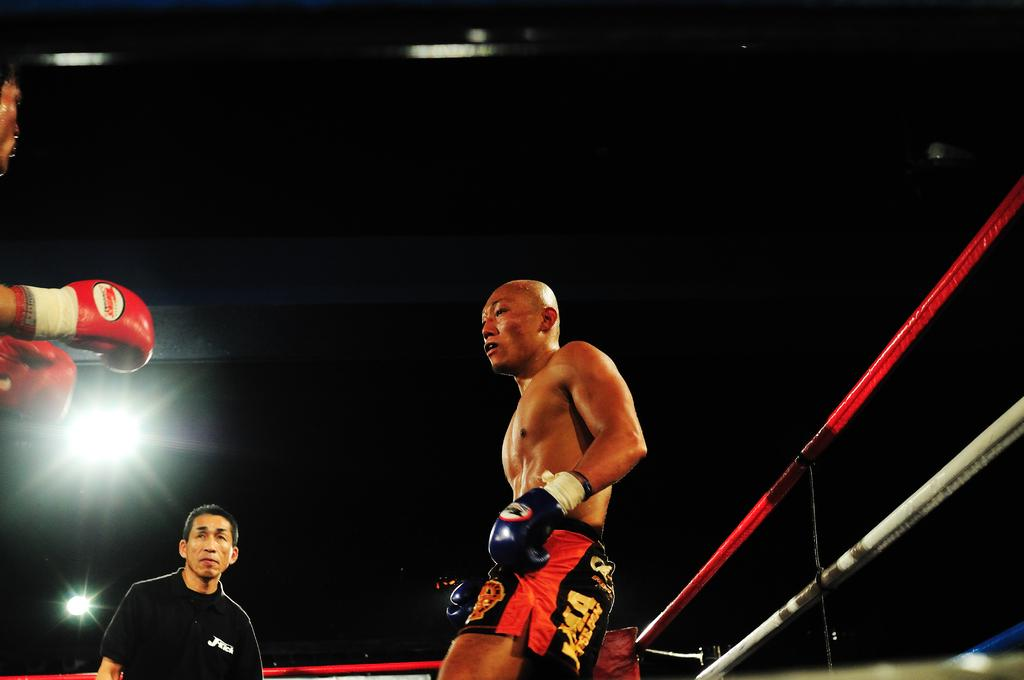Provide a one-sentence caption for the provided image. A referee stands between two boxers, one has the letters M.A printed on his trunks. 